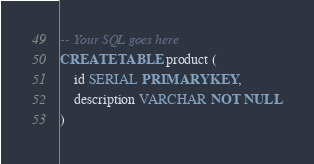<code> <loc_0><loc_0><loc_500><loc_500><_SQL_>-- Your SQL goes here
CREATE TABLE product (
    id SERIAL PRIMARY KEY,
    description VARCHAR NOT NULL
)</code> 